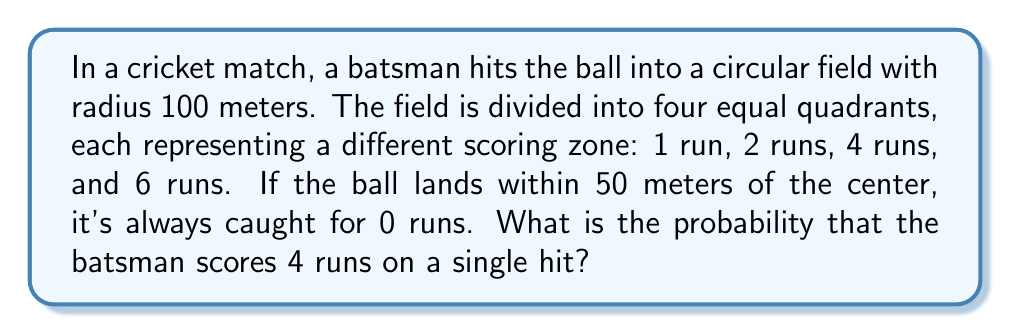Help me with this question. Let's approach this step-by-step using geometric probability:

1) The entire field is a circle with radius 100 meters. Its area is:
   $$A_{total} = \pi r^2 = \pi (100)^2 = 10000\pi \text{ m}^2$$

2) The inner circle where the ball is always caught has a radius of 50 meters. Its area is:
   $$A_{caught} = \pi r^2 = \pi (50)^2 = 2500\pi \text{ m}^2$$

3) The area where scoring is possible is the difference:
   $$A_{scoring} = A_{total} - A_{caught} = 10000\pi - 2500\pi = 7500\pi \text{ m}^2$$

4) This scoring area is divided into 4 equal quadrants. The area of each quadrant is:
   $$A_{quadrant} = \frac{A_{scoring}}{4} = \frac{7500\pi}{4} = 1875\pi \text{ m}^2$$

5) The probability of scoring 4 runs is the area of the 4-run quadrant divided by the total area:
   $$P(4 \text{ runs}) = \frac{A_{quadrant}}{A_{total}} = \frac{1875\pi}{10000\pi} = \frac{3}{16} = 0.1875$$

[asy]
import geometry;

unitsize(1cm);

draw(circle((0,0),10));
draw(circle((0,0),5));
draw((0,-10)--(0,10));
draw((-10,0)--(10,0));

label("1 run", (7,7));
label("2 runs", (-7,7));
label("4 runs", (-7,-7));
label("6 runs", (7,-7));
label("Caught (0 runs)", (0,0));
[/asy]
Answer: $\frac{3}{16}$ or 0.1875 